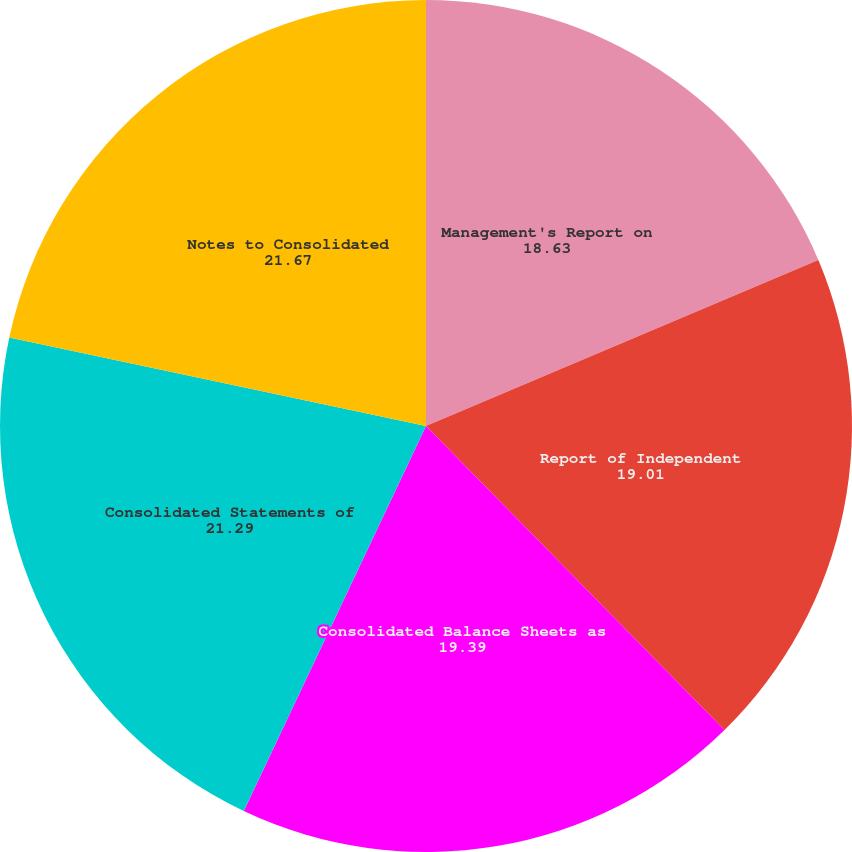Convert chart to OTSL. <chart><loc_0><loc_0><loc_500><loc_500><pie_chart><fcel>Management's Report on<fcel>Report of Independent<fcel>Consolidated Balance Sheets as<fcel>Consolidated Statements of<fcel>Notes to Consolidated<nl><fcel>18.63%<fcel>19.01%<fcel>19.39%<fcel>21.29%<fcel>21.67%<nl></chart> 